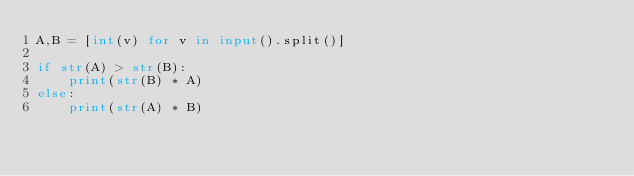Convert code to text. <code><loc_0><loc_0><loc_500><loc_500><_Python_>A,B = [int(v) for v in input().split()]

if str(A) > str(B):
    print(str(B) * A)
else:
    print(str(A) * B)
</code> 